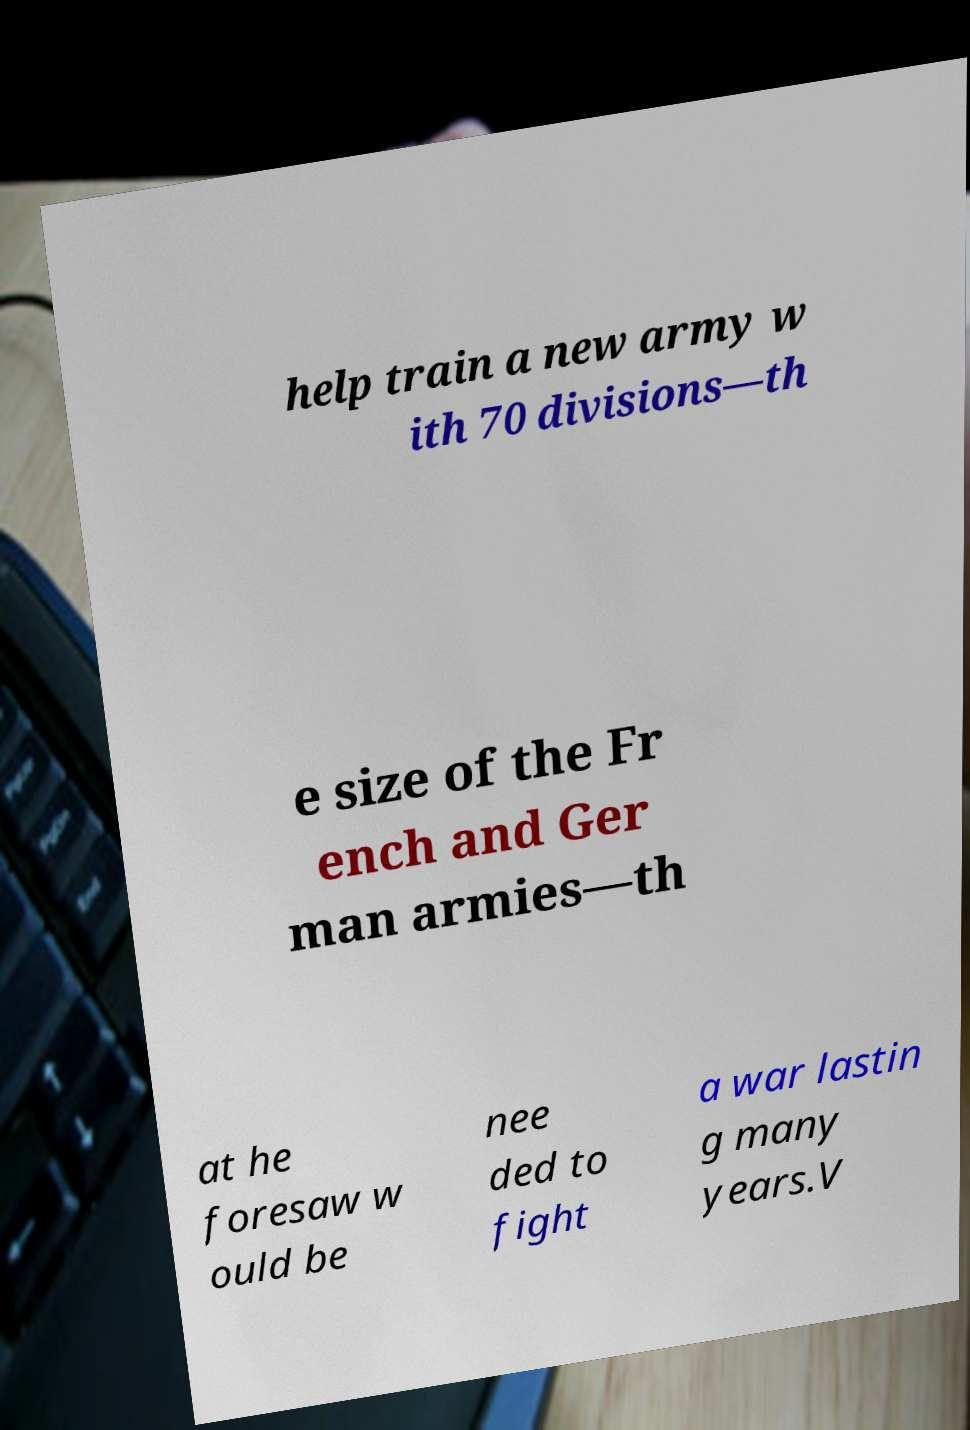There's text embedded in this image that I need extracted. Can you transcribe it verbatim? help train a new army w ith 70 divisions—th e size of the Fr ench and Ger man armies—th at he foresaw w ould be nee ded to fight a war lastin g many years.V 